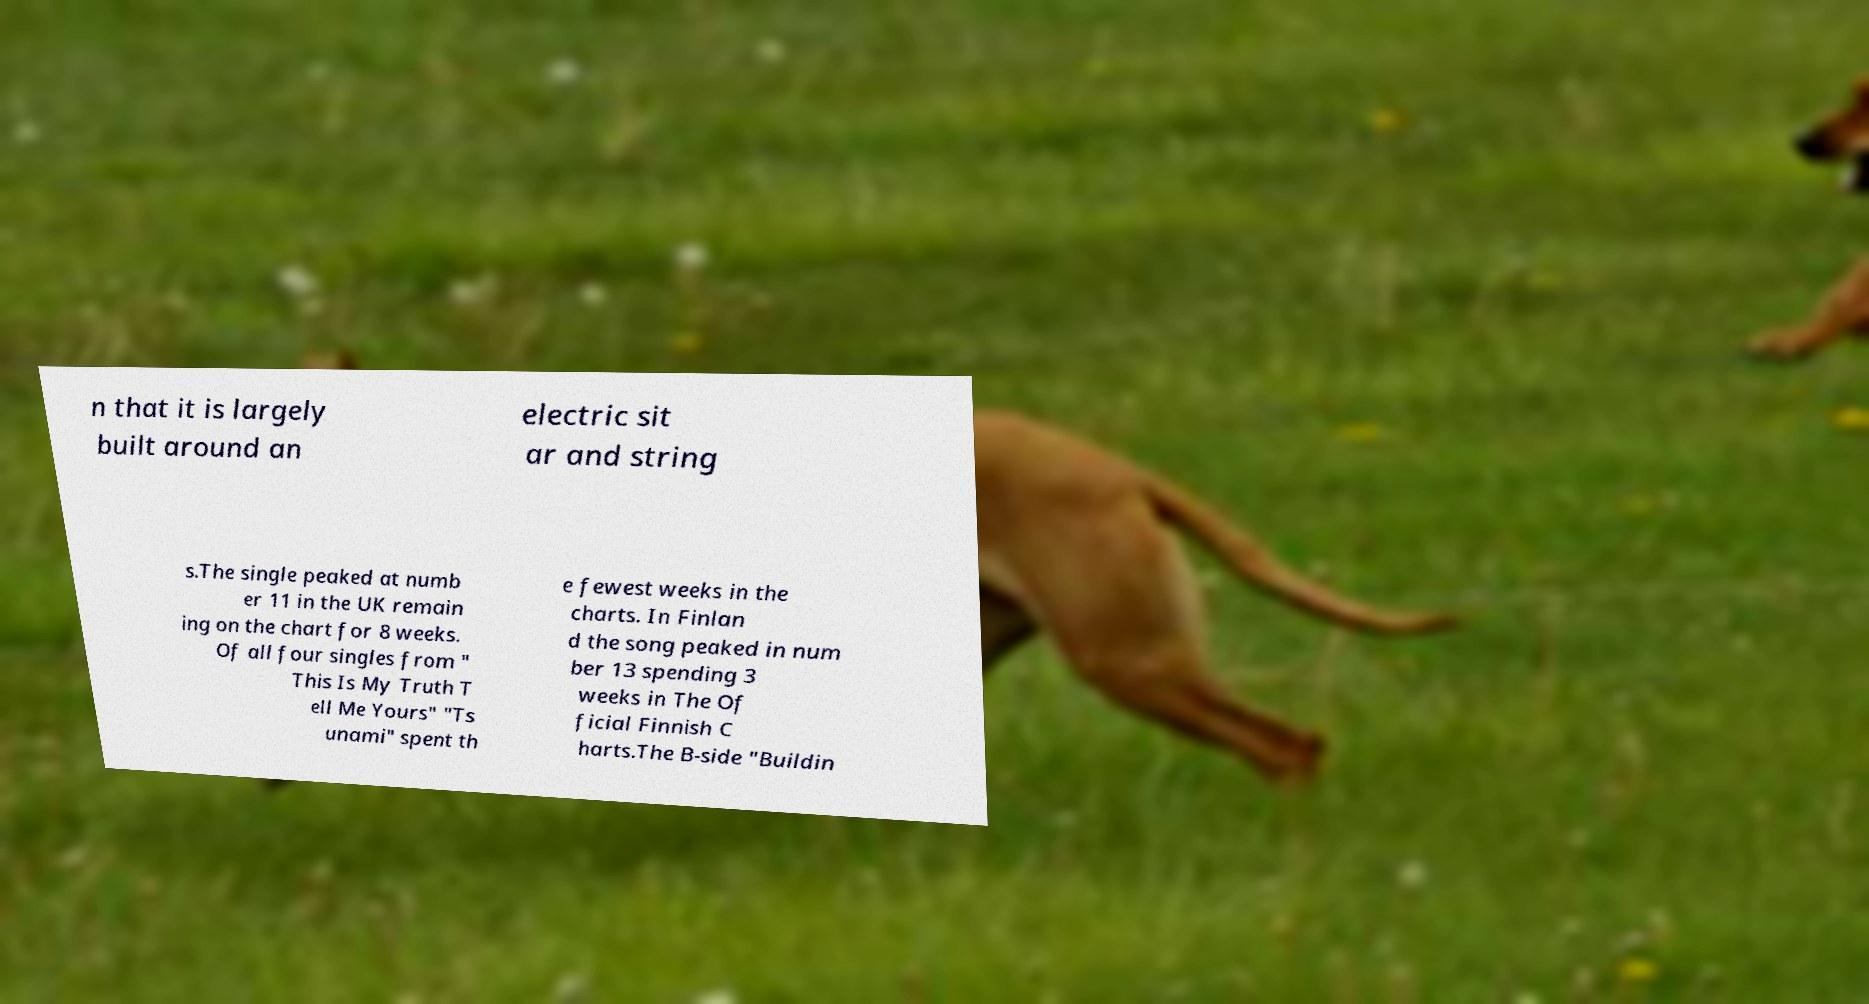I need the written content from this picture converted into text. Can you do that? n that it is largely built around an electric sit ar and string s.The single peaked at numb er 11 in the UK remain ing on the chart for 8 weeks. Of all four singles from " This Is My Truth T ell Me Yours" "Ts unami" spent th e fewest weeks in the charts. In Finlan d the song peaked in num ber 13 spending 3 weeks in The Of ficial Finnish C harts.The B-side "Buildin 